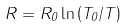Convert formula to latex. <formula><loc_0><loc_0><loc_500><loc_500>R = R _ { 0 } \ln \left ( T _ { 0 } / T \right )</formula> 